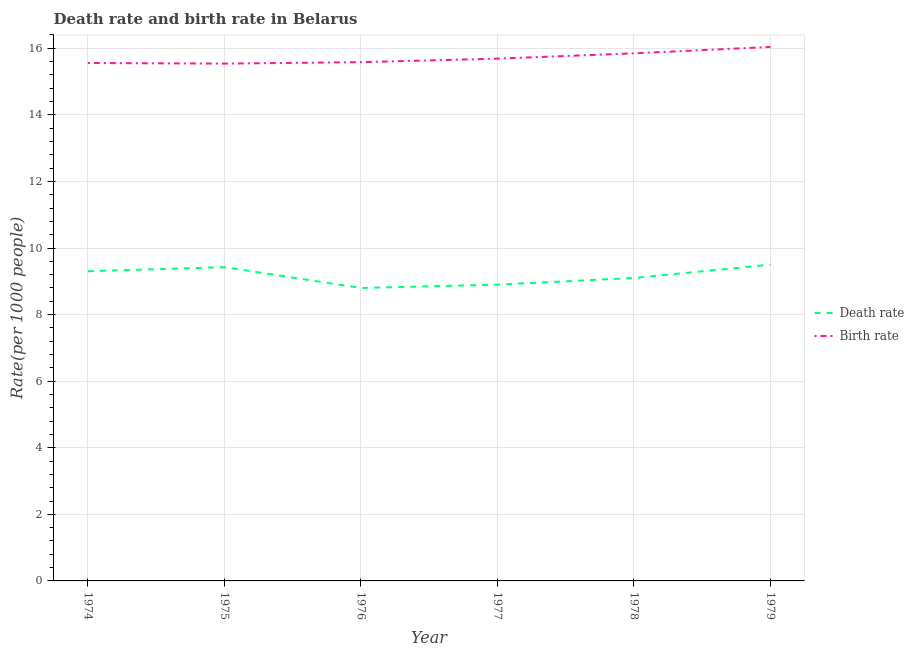Is the number of lines equal to the number of legend labels?
Your response must be concise. Yes. What is the birth rate in 1975?
Ensure brevity in your answer.  15.54. Across all years, what is the maximum birth rate?
Your answer should be compact. 16.04. In which year was the death rate maximum?
Give a very brief answer. 1979. In which year was the birth rate minimum?
Provide a short and direct response. 1975. What is the total birth rate in the graph?
Provide a short and direct response. 94.26. What is the difference between the birth rate in 1974 and that in 1978?
Ensure brevity in your answer.  -0.29. What is the difference between the death rate in 1979 and the birth rate in 1975?
Your answer should be very brief. -6.04. What is the average death rate per year?
Provide a succinct answer. 9.17. In the year 1976, what is the difference between the death rate and birth rate?
Provide a succinct answer. -6.78. In how many years, is the death rate greater than 4.4?
Offer a terse response. 6. What is the ratio of the death rate in 1975 to that in 1978?
Give a very brief answer. 1.04. Is the birth rate in 1975 less than that in 1978?
Your response must be concise. Yes. Is the difference between the death rate in 1978 and 1979 greater than the difference between the birth rate in 1978 and 1979?
Keep it short and to the point. No. What is the difference between the highest and the second highest death rate?
Your answer should be compact. 0.07. What is the difference between the highest and the lowest birth rate?
Your response must be concise. 0.5. In how many years, is the birth rate greater than the average birth rate taken over all years?
Provide a succinct answer. 2. Is the sum of the birth rate in 1974 and 1975 greater than the maximum death rate across all years?
Provide a short and direct response. Yes. How many lines are there?
Keep it short and to the point. 2. How many years are there in the graph?
Your answer should be compact. 6. Does the graph contain any zero values?
Your answer should be compact. No. Does the graph contain grids?
Offer a terse response. Yes. What is the title of the graph?
Provide a short and direct response. Death rate and birth rate in Belarus. What is the label or title of the X-axis?
Make the answer very short. Year. What is the label or title of the Y-axis?
Make the answer very short. Rate(per 1000 people). What is the Rate(per 1000 people) of Death rate in 1974?
Your answer should be compact. 9.3. What is the Rate(per 1000 people) of Birth rate in 1974?
Offer a terse response. 15.56. What is the Rate(per 1000 people) of Death rate in 1975?
Give a very brief answer. 9.43. What is the Rate(per 1000 people) of Birth rate in 1975?
Keep it short and to the point. 15.54. What is the Rate(per 1000 people) of Death rate in 1976?
Your answer should be very brief. 8.8. What is the Rate(per 1000 people) in Birth rate in 1976?
Keep it short and to the point. 15.58. What is the Rate(per 1000 people) of Death rate in 1977?
Offer a very short reply. 8.9. What is the Rate(per 1000 people) of Birth rate in 1977?
Give a very brief answer. 15.69. What is the Rate(per 1000 people) of Death rate in 1978?
Provide a short and direct response. 9.1. What is the Rate(per 1000 people) in Birth rate in 1978?
Provide a short and direct response. 15.85. What is the Rate(per 1000 people) in Birth rate in 1979?
Provide a succinct answer. 16.04. Across all years, what is the maximum Rate(per 1000 people) in Death rate?
Your answer should be very brief. 9.5. Across all years, what is the maximum Rate(per 1000 people) in Birth rate?
Make the answer very short. 16.04. Across all years, what is the minimum Rate(per 1000 people) in Birth rate?
Your answer should be compact. 15.54. What is the total Rate(per 1000 people) in Death rate in the graph?
Make the answer very short. 55.03. What is the total Rate(per 1000 people) of Birth rate in the graph?
Keep it short and to the point. 94.26. What is the difference between the Rate(per 1000 people) of Death rate in 1974 and that in 1975?
Offer a very short reply. -0.12. What is the difference between the Rate(per 1000 people) of Birth rate in 1974 and that in 1975?
Ensure brevity in your answer.  0.02. What is the difference between the Rate(per 1000 people) of Death rate in 1974 and that in 1976?
Your response must be concise. 0.5. What is the difference between the Rate(per 1000 people) in Birth rate in 1974 and that in 1976?
Provide a succinct answer. -0.03. What is the difference between the Rate(per 1000 people) of Death rate in 1974 and that in 1977?
Your response must be concise. 0.4. What is the difference between the Rate(per 1000 people) of Birth rate in 1974 and that in 1977?
Your answer should be very brief. -0.13. What is the difference between the Rate(per 1000 people) of Death rate in 1974 and that in 1978?
Provide a succinct answer. 0.2. What is the difference between the Rate(per 1000 people) of Birth rate in 1974 and that in 1978?
Ensure brevity in your answer.  -0.29. What is the difference between the Rate(per 1000 people) in Death rate in 1974 and that in 1979?
Offer a terse response. -0.2. What is the difference between the Rate(per 1000 people) in Birth rate in 1974 and that in 1979?
Your answer should be compact. -0.48. What is the difference between the Rate(per 1000 people) in Death rate in 1975 and that in 1976?
Offer a terse response. 0.62. What is the difference between the Rate(per 1000 people) in Birth rate in 1975 and that in 1976?
Keep it short and to the point. -0.04. What is the difference between the Rate(per 1000 people) in Death rate in 1975 and that in 1977?
Keep it short and to the point. 0.53. What is the difference between the Rate(per 1000 people) in Birth rate in 1975 and that in 1977?
Your answer should be very brief. -0.15. What is the difference between the Rate(per 1000 people) in Death rate in 1975 and that in 1978?
Your answer should be very brief. 0.33. What is the difference between the Rate(per 1000 people) of Birth rate in 1975 and that in 1978?
Offer a terse response. -0.31. What is the difference between the Rate(per 1000 people) in Death rate in 1975 and that in 1979?
Your answer should be very brief. -0.07. What is the difference between the Rate(per 1000 people) in Birth rate in 1975 and that in 1979?
Your answer should be very brief. -0.5. What is the difference between the Rate(per 1000 people) of Birth rate in 1976 and that in 1977?
Offer a very short reply. -0.11. What is the difference between the Rate(per 1000 people) of Death rate in 1976 and that in 1978?
Keep it short and to the point. -0.3. What is the difference between the Rate(per 1000 people) of Birth rate in 1976 and that in 1978?
Offer a terse response. -0.27. What is the difference between the Rate(per 1000 people) in Death rate in 1976 and that in 1979?
Offer a terse response. -0.7. What is the difference between the Rate(per 1000 people) in Birth rate in 1976 and that in 1979?
Give a very brief answer. -0.46. What is the difference between the Rate(per 1000 people) of Birth rate in 1977 and that in 1978?
Offer a terse response. -0.16. What is the difference between the Rate(per 1000 people) in Death rate in 1977 and that in 1979?
Your response must be concise. -0.6. What is the difference between the Rate(per 1000 people) in Birth rate in 1977 and that in 1979?
Offer a very short reply. -0.35. What is the difference between the Rate(per 1000 people) of Death rate in 1978 and that in 1979?
Offer a terse response. -0.4. What is the difference between the Rate(per 1000 people) in Birth rate in 1978 and that in 1979?
Ensure brevity in your answer.  -0.19. What is the difference between the Rate(per 1000 people) in Death rate in 1974 and the Rate(per 1000 people) in Birth rate in 1975?
Keep it short and to the point. -6.24. What is the difference between the Rate(per 1000 people) of Death rate in 1974 and the Rate(per 1000 people) of Birth rate in 1976?
Keep it short and to the point. -6.28. What is the difference between the Rate(per 1000 people) in Death rate in 1974 and the Rate(per 1000 people) in Birth rate in 1977?
Your answer should be very brief. -6.39. What is the difference between the Rate(per 1000 people) in Death rate in 1974 and the Rate(per 1000 people) in Birth rate in 1978?
Provide a short and direct response. -6.55. What is the difference between the Rate(per 1000 people) of Death rate in 1974 and the Rate(per 1000 people) of Birth rate in 1979?
Provide a succinct answer. -6.74. What is the difference between the Rate(per 1000 people) of Death rate in 1975 and the Rate(per 1000 people) of Birth rate in 1976?
Keep it short and to the point. -6.16. What is the difference between the Rate(per 1000 people) of Death rate in 1975 and the Rate(per 1000 people) of Birth rate in 1977?
Your response must be concise. -6.26. What is the difference between the Rate(per 1000 people) of Death rate in 1975 and the Rate(per 1000 people) of Birth rate in 1978?
Give a very brief answer. -6.42. What is the difference between the Rate(per 1000 people) in Death rate in 1975 and the Rate(per 1000 people) in Birth rate in 1979?
Make the answer very short. -6.62. What is the difference between the Rate(per 1000 people) of Death rate in 1976 and the Rate(per 1000 people) of Birth rate in 1977?
Keep it short and to the point. -6.89. What is the difference between the Rate(per 1000 people) in Death rate in 1976 and the Rate(per 1000 people) in Birth rate in 1978?
Make the answer very short. -7.05. What is the difference between the Rate(per 1000 people) in Death rate in 1976 and the Rate(per 1000 people) in Birth rate in 1979?
Give a very brief answer. -7.24. What is the difference between the Rate(per 1000 people) of Death rate in 1977 and the Rate(per 1000 people) of Birth rate in 1978?
Provide a short and direct response. -6.95. What is the difference between the Rate(per 1000 people) in Death rate in 1977 and the Rate(per 1000 people) in Birth rate in 1979?
Provide a succinct answer. -7.14. What is the difference between the Rate(per 1000 people) in Death rate in 1978 and the Rate(per 1000 people) in Birth rate in 1979?
Offer a terse response. -6.94. What is the average Rate(per 1000 people) in Death rate per year?
Ensure brevity in your answer.  9.17. What is the average Rate(per 1000 people) in Birth rate per year?
Ensure brevity in your answer.  15.71. In the year 1974, what is the difference between the Rate(per 1000 people) of Death rate and Rate(per 1000 people) of Birth rate?
Make the answer very short. -6.25. In the year 1975, what is the difference between the Rate(per 1000 people) in Death rate and Rate(per 1000 people) in Birth rate?
Your answer should be compact. -6.12. In the year 1976, what is the difference between the Rate(per 1000 people) of Death rate and Rate(per 1000 people) of Birth rate?
Give a very brief answer. -6.78. In the year 1977, what is the difference between the Rate(per 1000 people) in Death rate and Rate(per 1000 people) in Birth rate?
Keep it short and to the point. -6.79. In the year 1978, what is the difference between the Rate(per 1000 people) of Death rate and Rate(per 1000 people) of Birth rate?
Give a very brief answer. -6.75. In the year 1979, what is the difference between the Rate(per 1000 people) of Death rate and Rate(per 1000 people) of Birth rate?
Give a very brief answer. -6.54. What is the ratio of the Rate(per 1000 people) of Death rate in 1974 to that in 1975?
Your answer should be compact. 0.99. What is the ratio of the Rate(per 1000 people) of Death rate in 1974 to that in 1976?
Your answer should be very brief. 1.06. What is the ratio of the Rate(per 1000 people) of Death rate in 1974 to that in 1977?
Make the answer very short. 1.05. What is the ratio of the Rate(per 1000 people) in Death rate in 1974 to that in 1978?
Give a very brief answer. 1.02. What is the ratio of the Rate(per 1000 people) of Birth rate in 1974 to that in 1978?
Your response must be concise. 0.98. What is the ratio of the Rate(per 1000 people) in Death rate in 1974 to that in 1979?
Your answer should be very brief. 0.98. What is the ratio of the Rate(per 1000 people) of Birth rate in 1974 to that in 1979?
Ensure brevity in your answer.  0.97. What is the ratio of the Rate(per 1000 people) of Death rate in 1975 to that in 1976?
Keep it short and to the point. 1.07. What is the ratio of the Rate(per 1000 people) in Death rate in 1975 to that in 1977?
Your answer should be very brief. 1.06. What is the ratio of the Rate(per 1000 people) of Birth rate in 1975 to that in 1977?
Your answer should be compact. 0.99. What is the ratio of the Rate(per 1000 people) of Death rate in 1975 to that in 1978?
Your answer should be very brief. 1.04. What is the ratio of the Rate(per 1000 people) in Birth rate in 1975 to that in 1978?
Keep it short and to the point. 0.98. What is the ratio of the Rate(per 1000 people) of Death rate in 1975 to that in 1979?
Provide a succinct answer. 0.99. What is the ratio of the Rate(per 1000 people) in Birth rate in 1975 to that in 1979?
Offer a very short reply. 0.97. What is the ratio of the Rate(per 1000 people) in Death rate in 1976 to that in 1977?
Keep it short and to the point. 0.99. What is the ratio of the Rate(per 1000 people) in Birth rate in 1976 to that in 1977?
Offer a very short reply. 0.99. What is the ratio of the Rate(per 1000 people) of Birth rate in 1976 to that in 1978?
Give a very brief answer. 0.98. What is the ratio of the Rate(per 1000 people) of Death rate in 1976 to that in 1979?
Your response must be concise. 0.93. What is the ratio of the Rate(per 1000 people) of Birth rate in 1976 to that in 1979?
Give a very brief answer. 0.97. What is the ratio of the Rate(per 1000 people) in Death rate in 1977 to that in 1979?
Keep it short and to the point. 0.94. What is the ratio of the Rate(per 1000 people) in Birth rate in 1977 to that in 1979?
Offer a terse response. 0.98. What is the ratio of the Rate(per 1000 people) of Death rate in 1978 to that in 1979?
Ensure brevity in your answer.  0.96. What is the ratio of the Rate(per 1000 people) in Birth rate in 1978 to that in 1979?
Ensure brevity in your answer.  0.99. What is the difference between the highest and the second highest Rate(per 1000 people) in Death rate?
Your answer should be very brief. 0.07. What is the difference between the highest and the second highest Rate(per 1000 people) of Birth rate?
Provide a succinct answer. 0.19. What is the difference between the highest and the lowest Rate(per 1000 people) of Death rate?
Offer a very short reply. 0.7. What is the difference between the highest and the lowest Rate(per 1000 people) in Birth rate?
Offer a very short reply. 0.5. 